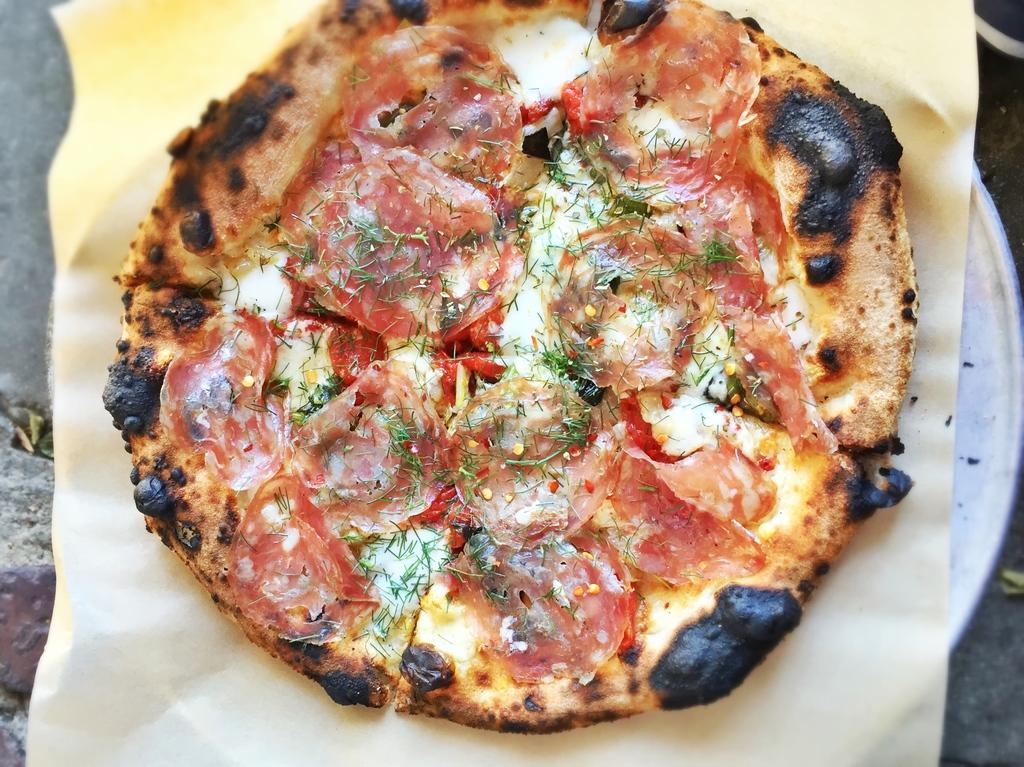What type of food is visible in the image? There is a pizza in the image. What is the pizza placed on? The pizza is on a tissue. What type of bubble can be seen surrounding the pizza in the image? There is no bubble present in the image; the pizza is on a tissue. 